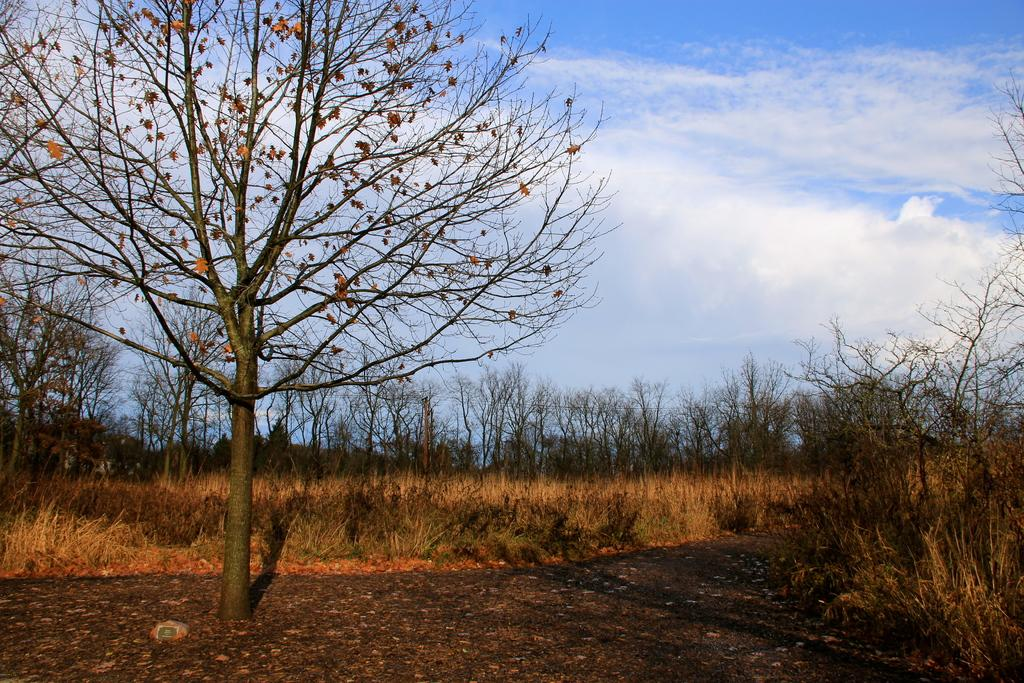What type of vegetation can be seen in the image? There are many trees, plants, and grass in the image. What is located at the bottom of the image? There is a road at the bottom of the image. What is visible at the top of the image? The sky is visible at the top of the image. What can be seen in the sky? Clouds are present in the sky. What type of credit card is visible in the image? There is no credit card present in the image. What type of voyage is depicted in the image? The image does not depict a voyage; it shows a natural landscape with trees, plants, grass, a road, and the sky with clouds. 